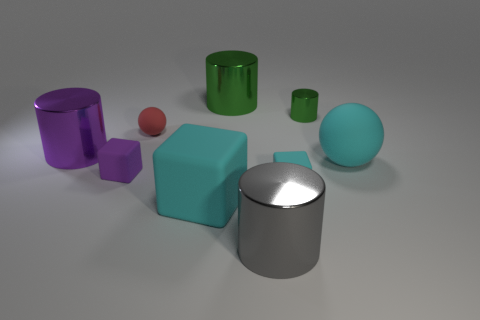What is the material of the large object that is the same shape as the small cyan rubber object?
Offer a very short reply. Rubber. The large sphere is what color?
Your answer should be very brief. Cyan. Is the color of the tiny metallic cylinder the same as the large matte cube?
Offer a very short reply. No. What number of shiny objects are either tiny red objects or cylinders?
Your answer should be very brief. 4. Is there a gray cylinder that is on the left side of the metal object in front of the big metal cylinder that is left of the purple rubber thing?
Give a very brief answer. No. There is a purple thing that is the same material as the big cyan block; what is its size?
Offer a very short reply. Small. Are there any blocks on the left side of the gray metallic thing?
Your answer should be very brief. Yes. Are there any purple shiny cylinders that are on the right side of the matte block to the right of the gray cylinder?
Offer a terse response. No. Does the rubber ball that is behind the large purple thing have the same size as the shiny cylinder in front of the cyan sphere?
Keep it short and to the point. No. What number of small objects are either red metallic spheres or purple metallic objects?
Provide a short and direct response. 0. 